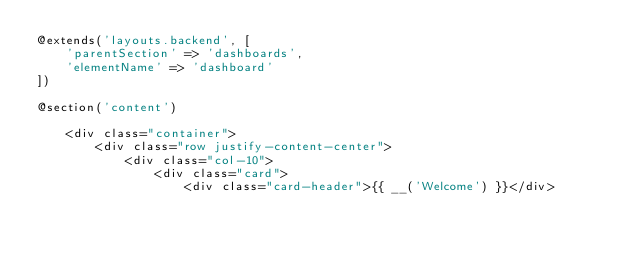Convert code to text. <code><loc_0><loc_0><loc_500><loc_500><_PHP_>@extends('layouts.backend', [
    'parentSection' => 'dashboards',
    'elementName' => 'dashboard'
])

@section('content')

    <div class="container">
        <div class="row justify-content-center">
            <div class="col-10">
                <div class="card">
                    <div class="card-header">{{ __('Welcome') }}</div>
</code> 